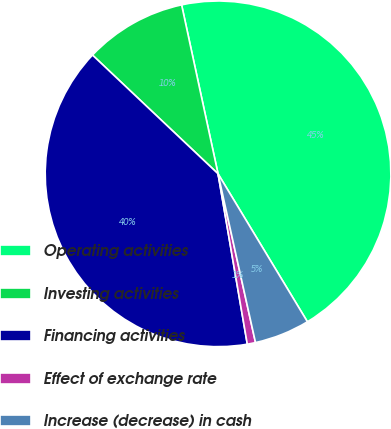Convert chart. <chart><loc_0><loc_0><loc_500><loc_500><pie_chart><fcel>Operating activities<fcel>Investing activities<fcel>Financing activities<fcel>Effect of exchange rate<fcel>Increase (decrease) in cash<nl><fcel>44.73%<fcel>9.56%<fcel>39.76%<fcel>0.77%<fcel>5.17%<nl></chart> 